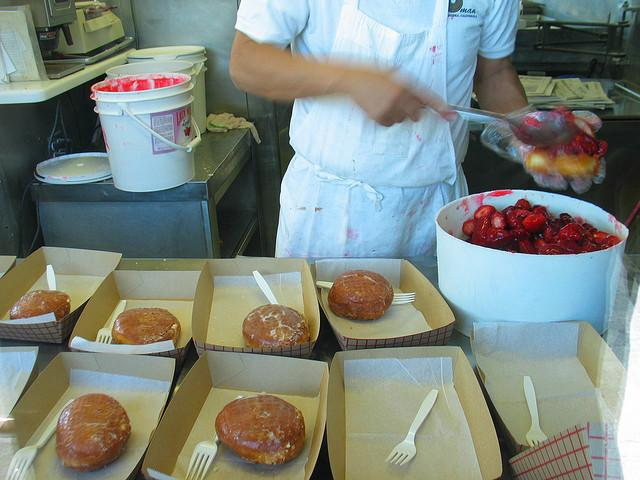What type of filling is in the donuts? strawberry 